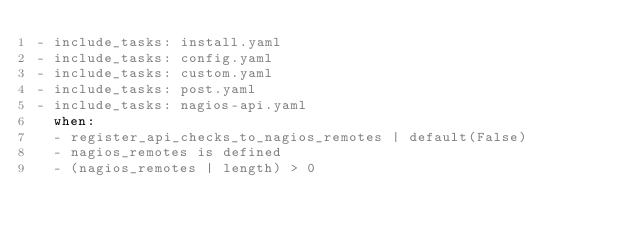Convert code to text. <code><loc_0><loc_0><loc_500><loc_500><_YAML_>- include_tasks: install.yaml
- include_tasks: config.yaml
- include_tasks: custom.yaml
- include_tasks: post.yaml
- include_tasks: nagios-api.yaml
  when:
  - register_api_checks_to_nagios_remotes | default(False)
  - nagios_remotes is defined
  - (nagios_remotes | length) > 0
</code> 